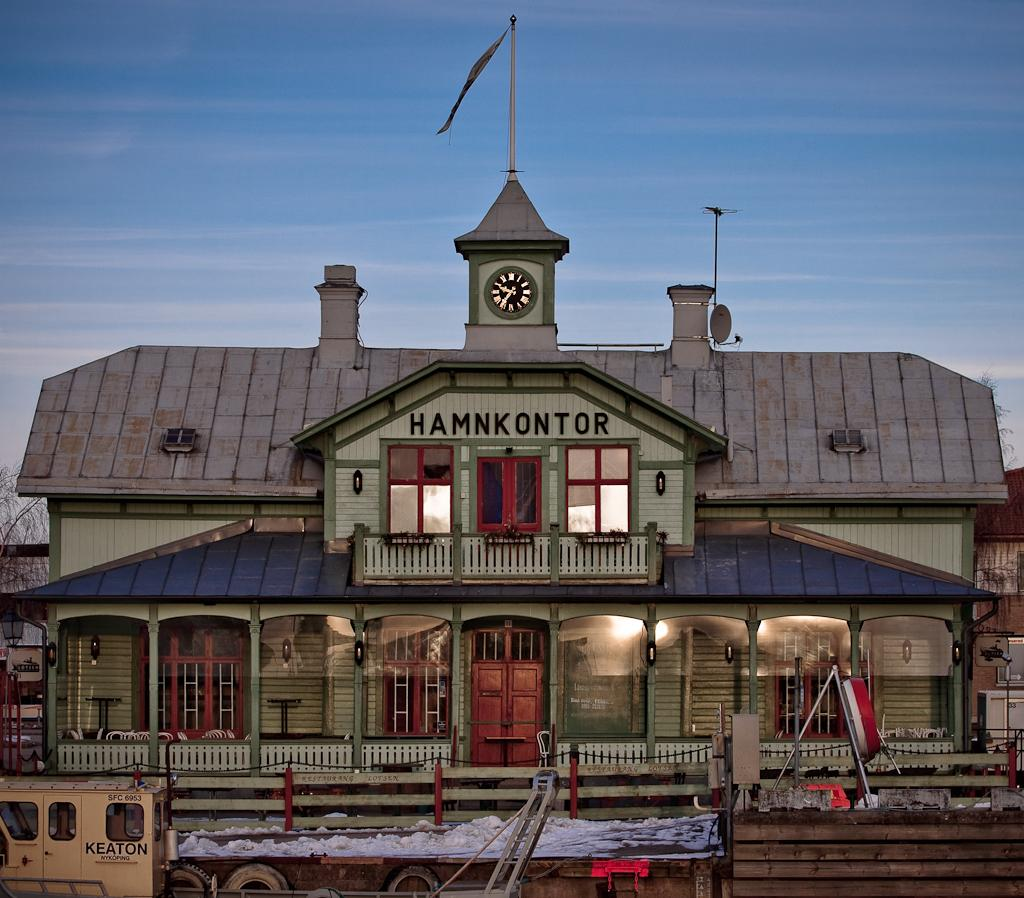What type of structures can be seen in the image? There are houses in the image. What architectural features are present on the houses? There are windows and doors visible on the houses. What time-keeping device is present in the image? There is a clock in the image. What can be seen in the sky in the image? The sky is visible in the image. What year is depicted in the image? The image does not depict a specific year; it is a photograph of houses, windows, doors, a clock, and the sky. What type of appliance can be seen in the image? There is no appliance present in the image. 